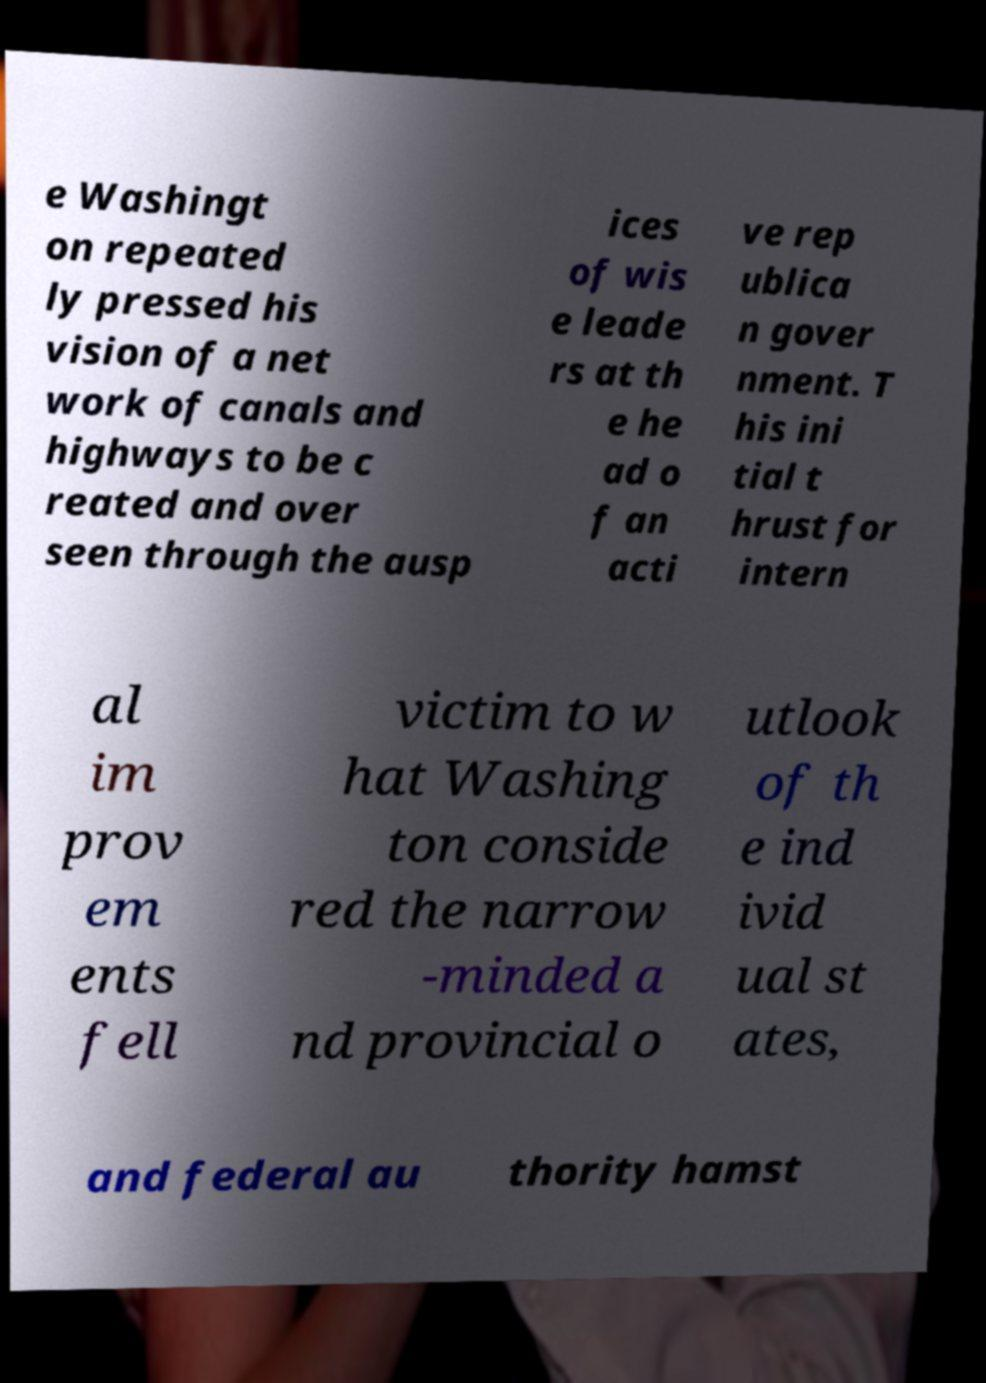Could you extract and type out the text from this image? e Washingt on repeated ly pressed his vision of a net work of canals and highways to be c reated and over seen through the ausp ices of wis e leade rs at th e he ad o f an acti ve rep ublica n gover nment. T his ini tial t hrust for intern al im prov em ents fell victim to w hat Washing ton conside red the narrow -minded a nd provincial o utlook of th e ind ivid ual st ates, and federal au thority hamst 